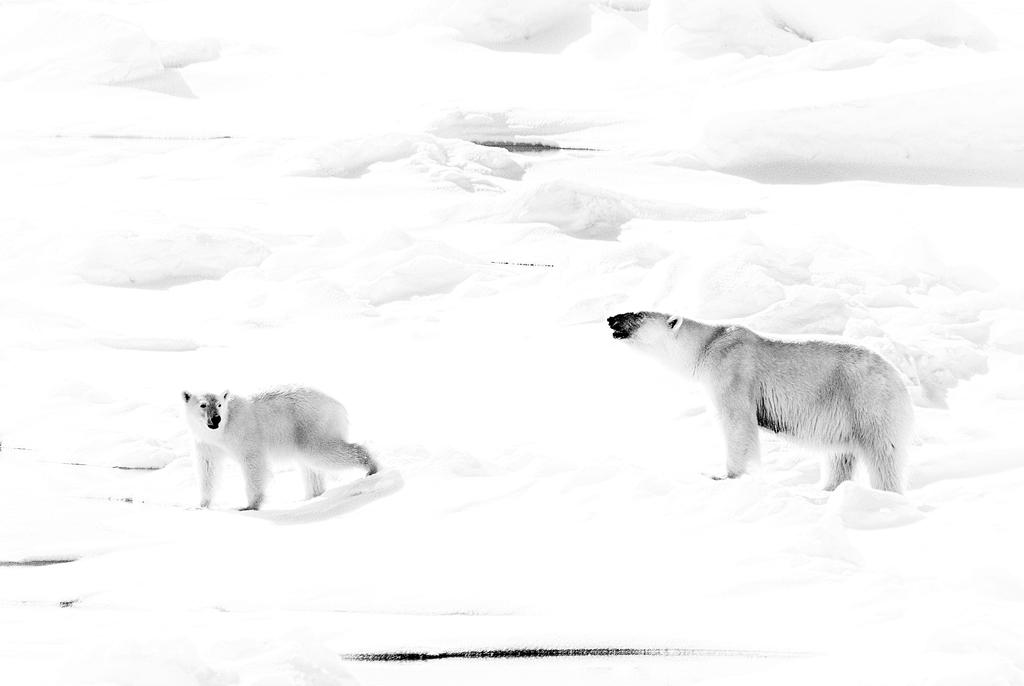What animals are in the foreground of the image? There are polar bears in the foreground of the image. What is the surface on which the polar bears are standing? The polar bears are on the snow. What can be seen in the background of the image? The background of the image consists of snow. What type of flowers can be seen growing in the snow in the image? There are no flowers present in the image; it features polar bears on the snow. Who is the writer in the image? There is no writer present in the image; it features polar bears on the snow. 